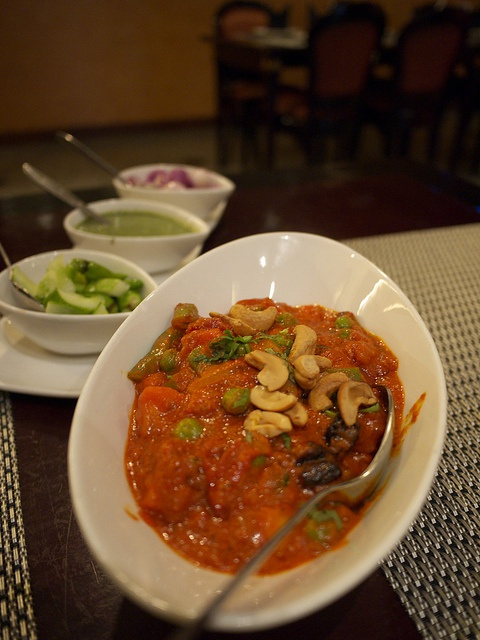Describe the objects in this image and their specific colors. I can see bowl in black, tan, maroon, and brown tones, dining table in black, tan, olive, and gray tones, dining table in black, gray, and tan tones, bowl in black, tan, olive, and gray tones, and chair in black and maroon tones in this image. 